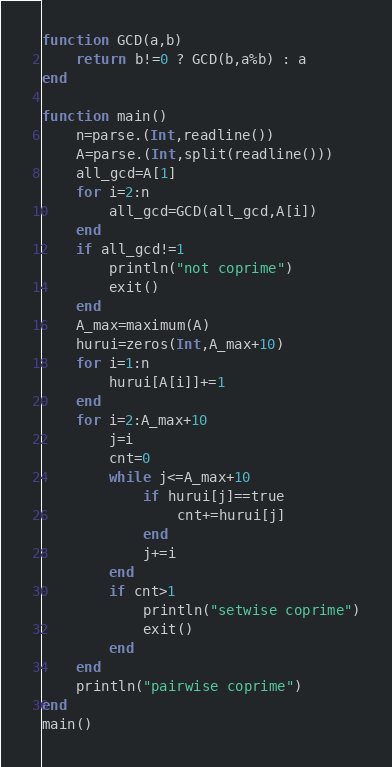<code> <loc_0><loc_0><loc_500><loc_500><_Julia_>function GCD(a,b)
    return b!=0 ? GCD(b,a%b) : a
end

function main()
    n=parse.(Int,readline())
    A=parse.(Int,split(readline()))
    all_gcd=A[1]
    for i=2:n
        all_gcd=GCD(all_gcd,A[i])
    end
    if all_gcd!=1
        println("not coprime")
        exit()
    end
    A_max=maximum(A)
    hurui=zeros(Int,A_max+10)
    for i=1:n
        hurui[A[i]]+=1
    end
    for i=2:A_max+10
        j=i
        cnt=0
        while j<=A_max+10
            if hurui[j]==true
                cnt+=hurui[j]
            end
            j+=i
        end
        if cnt>1
            println("setwise coprime")
            exit()
        end
    end
    println("pairwise coprime")
end
main()


</code> 